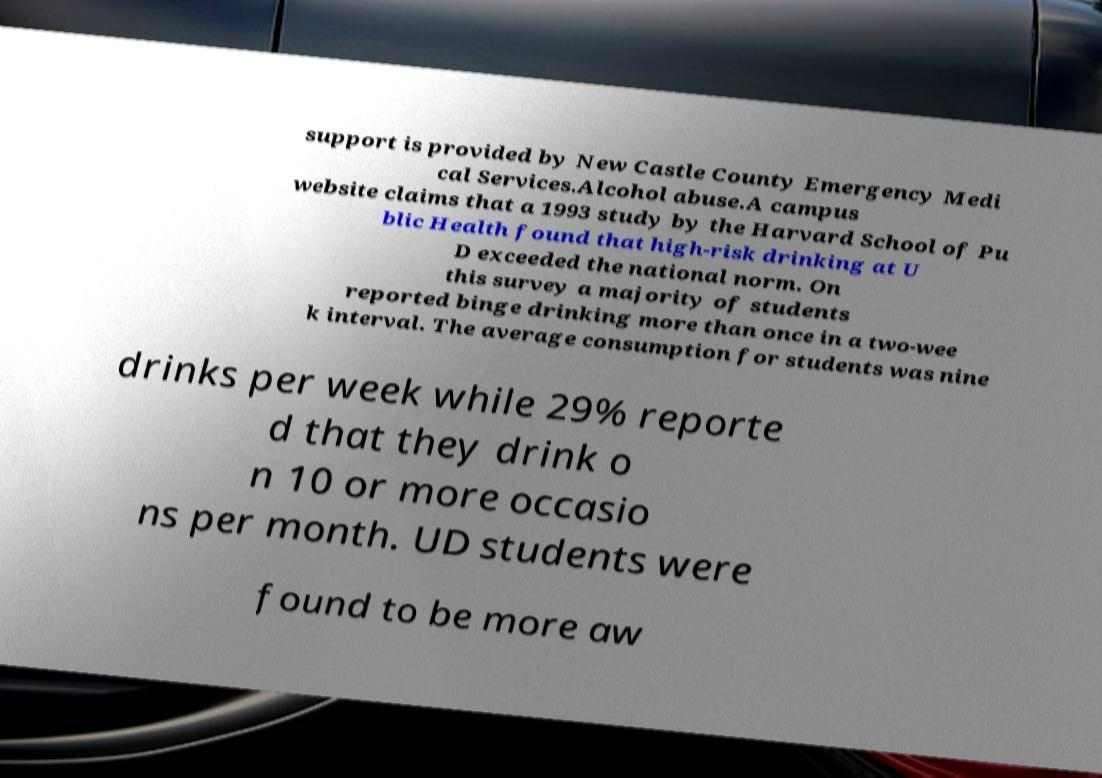There's text embedded in this image that I need extracted. Can you transcribe it verbatim? support is provided by New Castle County Emergency Medi cal Services.Alcohol abuse.A campus website claims that a 1993 study by the Harvard School of Pu blic Health found that high-risk drinking at U D exceeded the national norm. On this survey a majority of students reported binge drinking more than once in a two-wee k interval. The average consumption for students was nine drinks per week while 29% reporte d that they drink o n 10 or more occasio ns per month. UD students were found to be more aw 